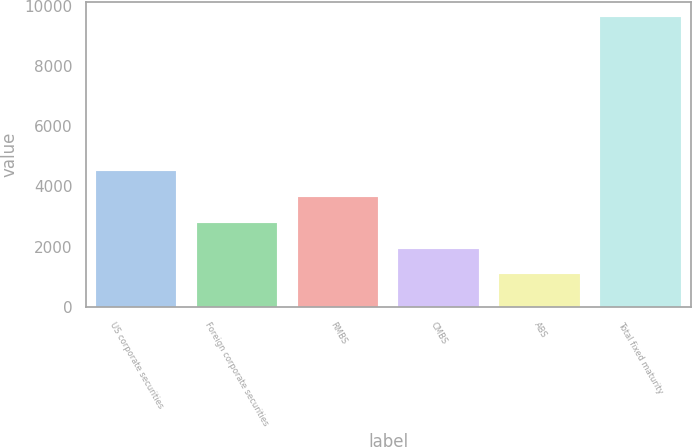<chart> <loc_0><loc_0><loc_500><loc_500><bar_chart><fcel>US corporate securities<fcel>Foreign corporate securities<fcel>RMBS<fcel>CMBS<fcel>ABS<fcel>Total fixed maturity<nl><fcel>4497<fcel>2787<fcel>3642<fcel>1932<fcel>1077<fcel>9627<nl></chart> 